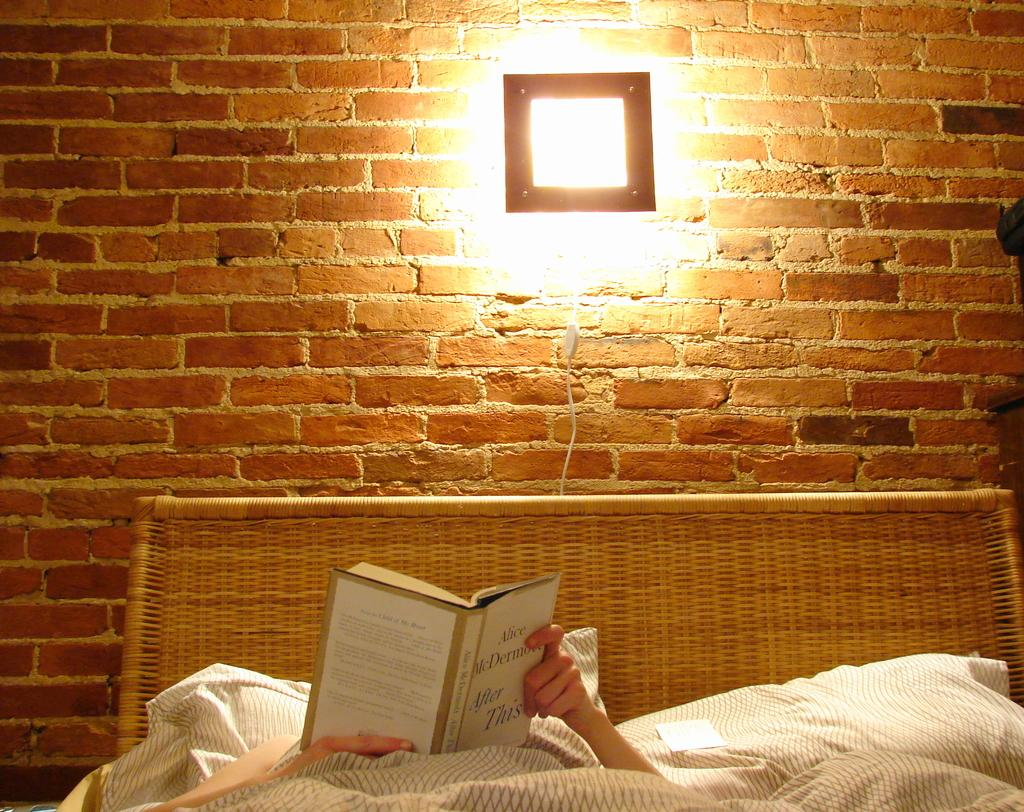What is the main structure in the middle of the image? There is a brick wall in the middle of the image. What is located at the bottom of the image? There is a bed at the bottom of the image. What is the person on the bed doing? The person is laying on the bed and holding a book. Where is the light source in the image? There is a light at the top of the image. What type of road can be seen in the image? There is no road present in the image. Can you describe the coastline visible in the image? There is no coastline visible in the image. 